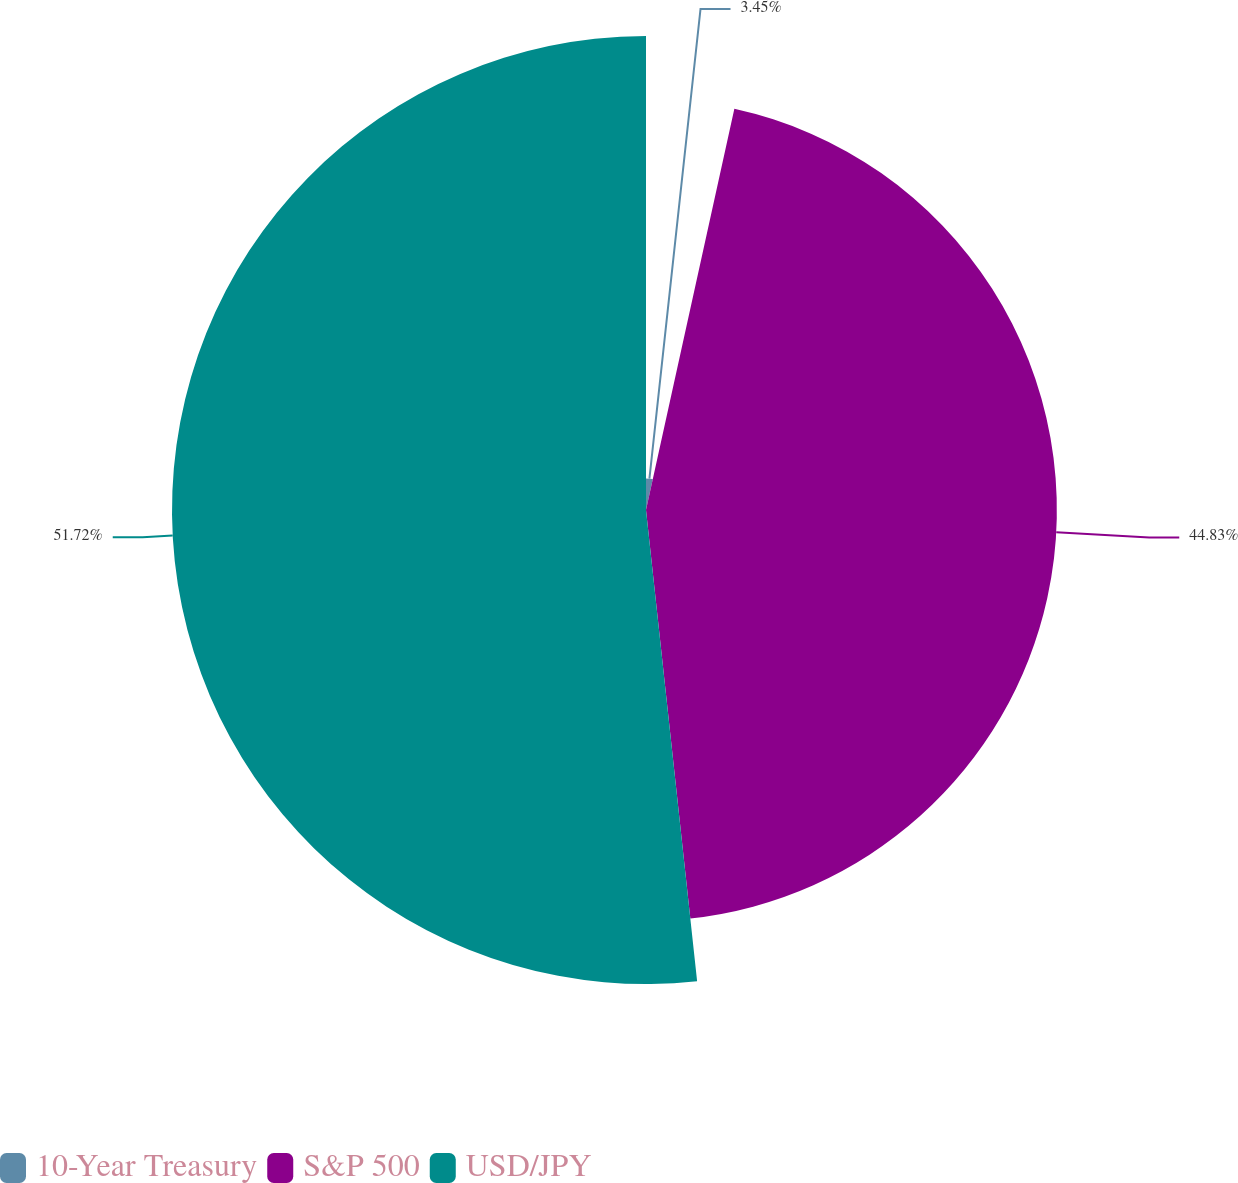Convert chart to OTSL. <chart><loc_0><loc_0><loc_500><loc_500><pie_chart><fcel>10-Year Treasury<fcel>S&P 500<fcel>USD/JPY<nl><fcel>3.45%<fcel>44.83%<fcel>51.72%<nl></chart> 